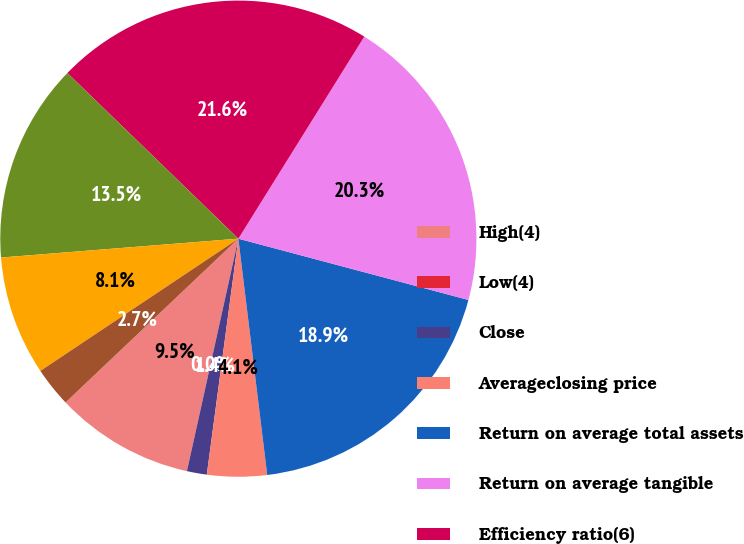<chart> <loc_0><loc_0><loc_500><loc_500><pie_chart><fcel>High(4)<fcel>Low(4)<fcel>Close<fcel>Averageclosing price<fcel>Return on average total assets<fcel>Return on average tangible<fcel>Efficiency ratio(6)<fcel>Effective tax rate (benefit)<fcel>Interest income(7)<fcel>Interest expense<nl><fcel>9.46%<fcel>0.0%<fcel>1.35%<fcel>4.05%<fcel>18.92%<fcel>20.27%<fcel>21.62%<fcel>13.51%<fcel>8.11%<fcel>2.7%<nl></chart> 